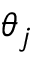<formula> <loc_0><loc_0><loc_500><loc_500>\theta _ { j }</formula> 